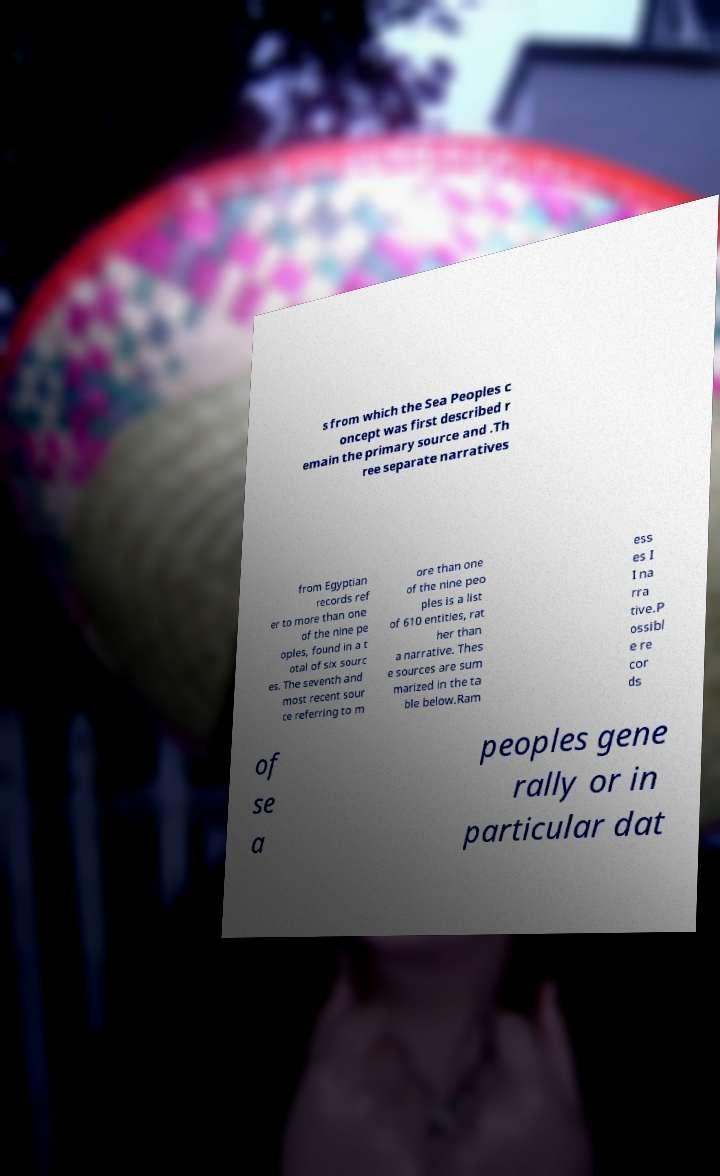I need the written content from this picture converted into text. Can you do that? s from which the Sea Peoples c oncept was first described r emain the primary source and .Th ree separate narratives from Egyptian records ref er to more than one of the nine pe oples, found in a t otal of six sourc es. The seventh and most recent sour ce referring to m ore than one of the nine peo ples is a list of 610 entities, rat her than a narrative. Thes e sources are sum marized in the ta ble below.Ram ess es I I na rra tive.P ossibl e re cor ds of se a peoples gene rally or in particular dat 